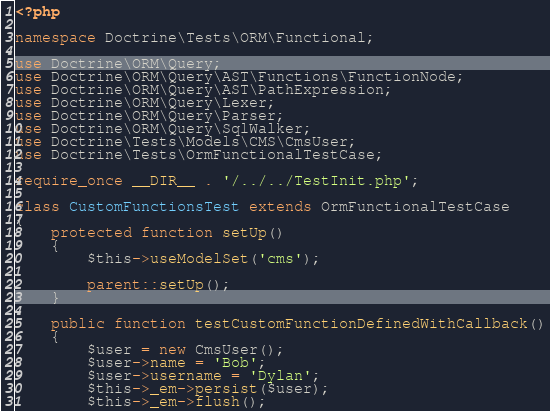Convert code to text. <code><loc_0><loc_0><loc_500><loc_500><_PHP_><?php

namespace Doctrine\Tests\ORM\Functional;

use Doctrine\ORM\Query;
use Doctrine\ORM\Query\AST\Functions\FunctionNode;
use Doctrine\ORM\Query\AST\PathExpression;
use Doctrine\ORM\Query\Lexer;
use Doctrine\ORM\Query\Parser;
use Doctrine\ORM\Query\SqlWalker;
use Doctrine\Tests\Models\CMS\CmsUser;
use Doctrine\Tests\OrmFunctionalTestCase;

require_once __DIR__ . '/../../TestInit.php';

class CustomFunctionsTest extends OrmFunctionalTestCase
{
    protected function setUp()
    {
        $this->useModelSet('cms');

        parent::setUp();
    }

    public function testCustomFunctionDefinedWithCallback()
    {
        $user = new CmsUser();
        $user->name = 'Bob';
        $user->username = 'Dylan';
        $this->_em->persist($user);
        $this->_em->flush();
</code> 